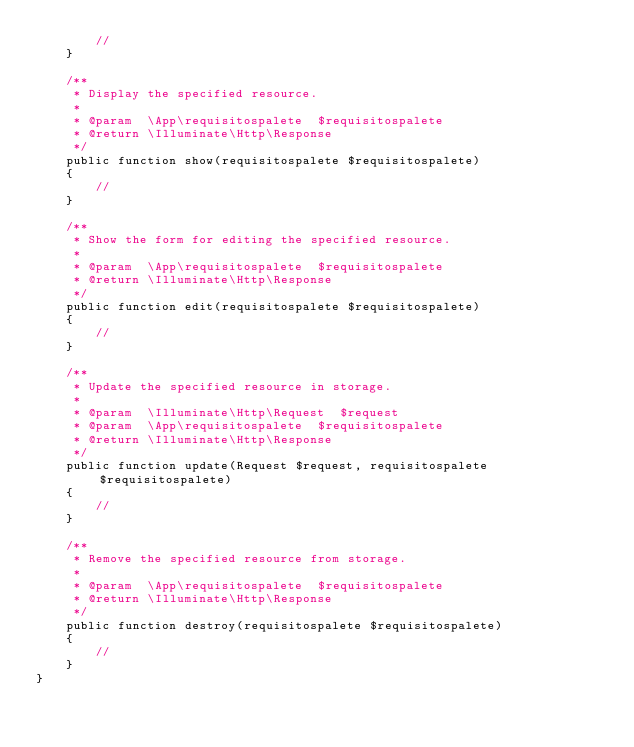Convert code to text. <code><loc_0><loc_0><loc_500><loc_500><_PHP_>        //
    }

    /**
     * Display the specified resource.
     *
     * @param  \App\requisitospalete  $requisitospalete
     * @return \Illuminate\Http\Response
     */
    public function show(requisitospalete $requisitospalete)
    {
        //
    }

    /**
     * Show the form for editing the specified resource.
     *
     * @param  \App\requisitospalete  $requisitospalete
     * @return \Illuminate\Http\Response
     */
    public function edit(requisitospalete $requisitospalete)
    {
        //
    }

    /**
     * Update the specified resource in storage.
     *
     * @param  \Illuminate\Http\Request  $request
     * @param  \App\requisitospalete  $requisitospalete
     * @return \Illuminate\Http\Response
     */
    public function update(Request $request, requisitospalete $requisitospalete)
    {
        //
    }

    /**
     * Remove the specified resource from storage.
     *
     * @param  \App\requisitospalete  $requisitospalete
     * @return \Illuminate\Http\Response
     */
    public function destroy(requisitospalete $requisitospalete)
    {
        //
    }
}
</code> 